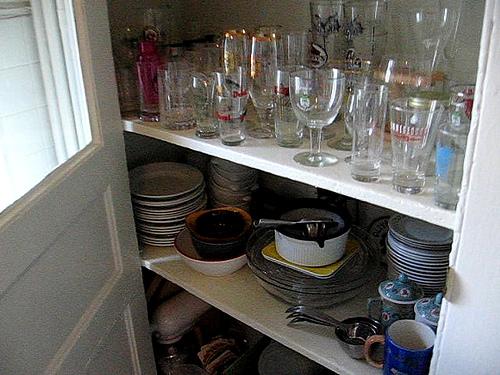What small appliance is on the bottom shelf?
Give a very brief answer. Mixer. Is the cabinet door open?
Keep it brief. Yes. Which room are these items found in?
Give a very brief answer. Kitchen. 